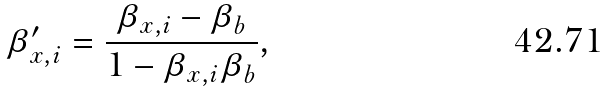<formula> <loc_0><loc_0><loc_500><loc_500>\beta ^ { \prime } _ { x , i } = \frac { \beta _ { x , i } - \beta _ { b } } { 1 - \beta _ { x , i } \beta _ { b } } ,</formula> 